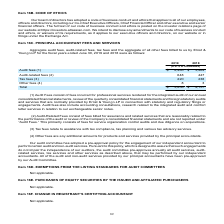According to Atlassian Plc's financial document, What is the definition of other fees? Any additional amounts for products and services provided by the principal accountants.. The document states: "(4) Other fees are any additional amounts for products and services provided by the principal accountants...." Also, What does tax fees refer to? Assistance with tax compliance, tax planning and various tax advisory services.. The document states: "(3) Tax fees relate to assistance with tax compliance, tax planning and various tax advisory services...." Also, What is the total fees for fiscal year ended June 30, 2019? According to the financial document, $3,856 (in thousands). The relevant text states: "Total $ 3,856 $ 4,157..." Also, can you calculate: What is the change in total fees between fiscal years 2018 and 2019? Based on the calculation: 3,856-4,157, the result is -301 (in thousands). This is based on the information: "Total $ 3,856 $ 4,157 Total $ 3,856 $ 4,157..." The key data points involved are: 3,856, 4,157. Also, can you calculate: What is the average tax fees for fiscal years 2018 and 2019? To answer this question, I need to perform calculations using the financial data. The calculation is: (220+238)/2, which equals 229 (in thousands). This is based on the information: "Tax fees (3) 220 238 Tax fees (3) 220 238..." The key data points involved are: 220, 238. Also, can you calculate: For fiscal year ended June 30, 2018, what is the percentage constitution of audit fees among the total fees? Based on the calculation: 3,469/4,157, the result is 83.45 (percentage). This is based on the information: "Total $ 3,856 $ 4,157 Audit fees (1) $ 2,980 $ 3,469..." The key data points involved are: 3,469, 4,157. 